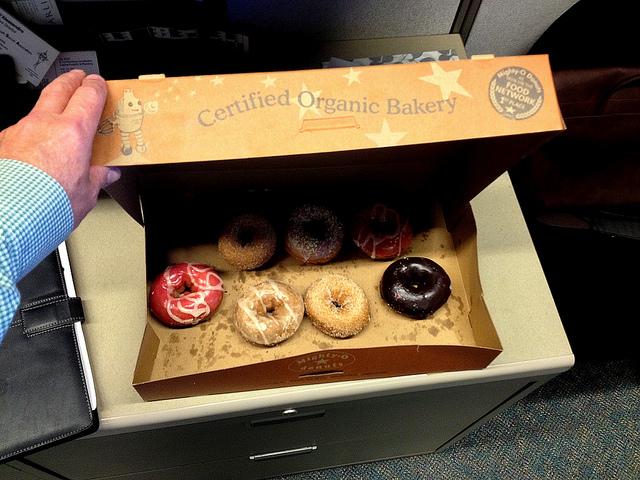What type of bakery is this from?
Answer briefly. Organic. Would a financially conscious person purchase these donuts?
Short answer required. No. Which donut would you prefer?
Answer briefly. Chocolate. 